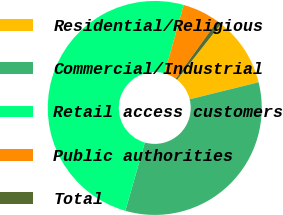Convert chart. <chart><loc_0><loc_0><loc_500><loc_500><pie_chart><fcel>Residential/Religious<fcel>Commercial/Industrial<fcel>Retail access customers<fcel>Public authorities<fcel>Total<nl><fcel>10.52%<fcel>33.29%<fcel>49.93%<fcel>5.59%<fcel>0.67%<nl></chart> 